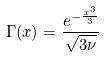<formula> <loc_0><loc_0><loc_500><loc_500>\Gamma ( x ) = \frac { e ^ { - \frac { x ^ { 3 } } { 3 } } } { \sqrt { 3 \nu } }</formula> 